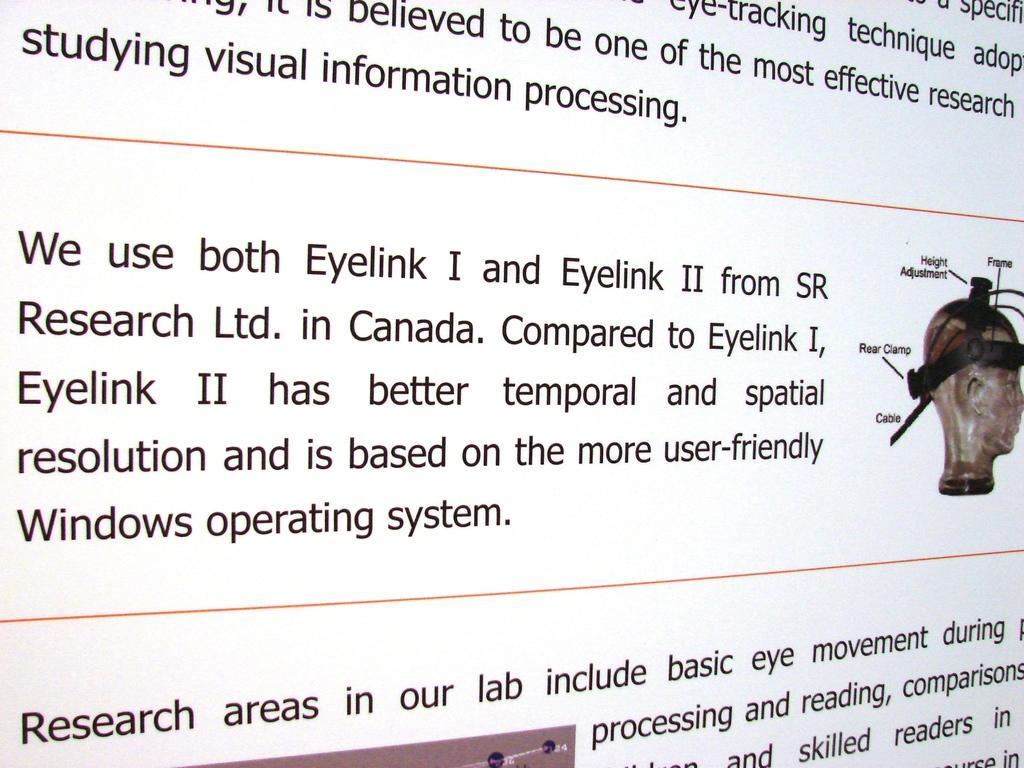In one or two sentences, can you explain what this image depicts? In the picture there is a poster with the text. 